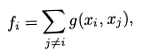Convert formula to latex. <formula><loc_0><loc_0><loc_500><loc_500>f _ { i } = \sum _ { j \ne i } g ( x _ { i } , x _ { j } ) ,</formula> 